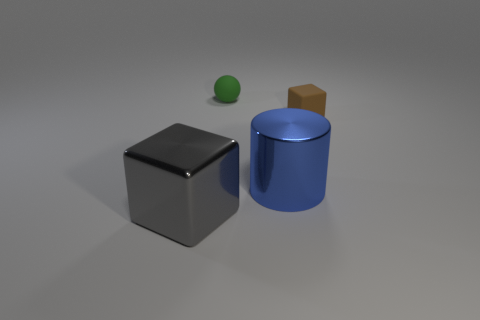Add 1 gray matte cylinders. How many objects exist? 5 Subtract all spheres. How many objects are left? 3 Subtract all gray cubes. How many cubes are left? 1 Subtract all green cylinders. How many brown spheres are left? 0 Subtract all brown things. Subtract all big blue metallic cylinders. How many objects are left? 2 Add 3 big blue shiny objects. How many big blue shiny objects are left? 4 Add 3 big metal cubes. How many big metal cubes exist? 4 Subtract 0 red cylinders. How many objects are left? 4 Subtract 1 cylinders. How many cylinders are left? 0 Subtract all purple cubes. Subtract all cyan spheres. How many cubes are left? 2 